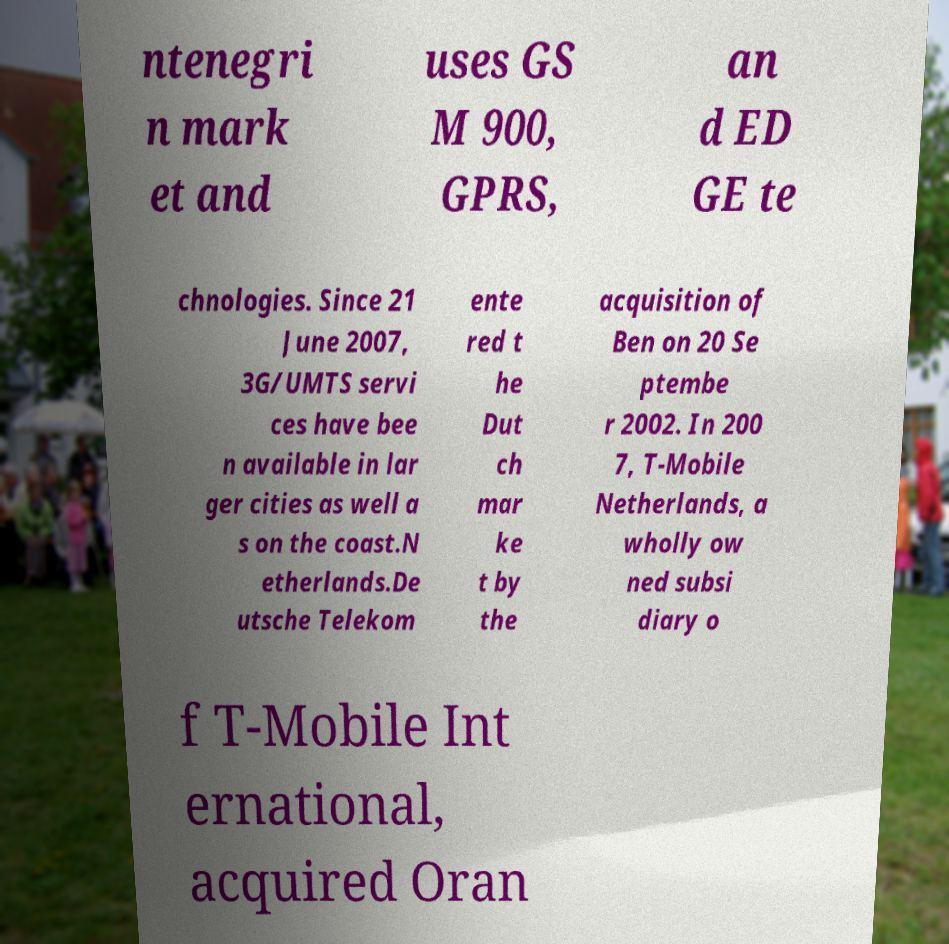Please read and relay the text visible in this image. What does it say? ntenegri n mark et and uses GS M 900, GPRS, an d ED GE te chnologies. Since 21 June 2007, 3G/UMTS servi ces have bee n available in lar ger cities as well a s on the coast.N etherlands.De utsche Telekom ente red t he Dut ch mar ke t by the acquisition of Ben on 20 Se ptembe r 2002. In 200 7, T-Mobile Netherlands, a wholly ow ned subsi diary o f T-Mobile Int ernational, acquired Oran 